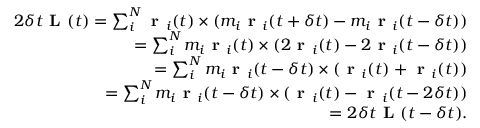Convert formula to latex. <formula><loc_0><loc_0><loc_500><loc_500>\begin{array} { r } { 2 \delta t L ( t ) = \sum _ { i } ^ { N } r _ { i } ( t ) \times ( m _ { i } r _ { i } ( t + \delta t ) - m _ { i } r _ { i } ( t - \delta t ) ) } \\ { = \sum _ { i } ^ { N } m _ { i } r _ { i } ( t ) \times ( 2 r _ { i } ( t ) - 2 r _ { i } ( t - \delta t ) ) } \\ { = \sum _ { i } ^ { N } m _ { i } r _ { i } ( t - \delta t ) \times ( r _ { i } ( t ) + r _ { i } ( t ) ) } \\ { = \sum _ { i } ^ { N } m _ { i } r _ { i } ( t - \delta t ) \times ( r _ { i } ( t ) - r _ { i } ( t - 2 \delta t ) ) } \\ { = 2 \delta t L ( t - \delta t ) . } \end{array}</formula> 